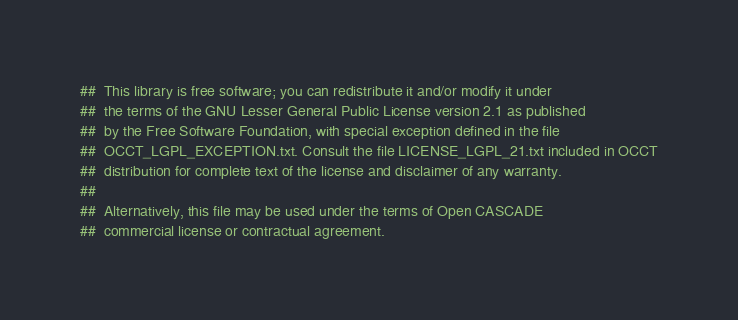<code> <loc_0><loc_0><loc_500><loc_500><_Nim_>##  This library is free software; you can redistribute it and/or modify it under
##  the terms of the GNU Lesser General Public License version 2.1 as published
##  by the Free Software Foundation, with special exception defined in the file
##  OCCT_LGPL_EXCEPTION.txt. Consult the file LICENSE_LGPL_21.txt included in OCCT
##  distribution for complete text of the license and disclaimer of any warranty.
##
##  Alternatively, this file may be used under the terms of Open CASCADE
##  commercial license or contractual agreement.
</code> 